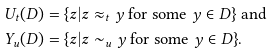<formula> <loc_0><loc_0><loc_500><loc_500>U _ { t } ( D ) & = \{ z | z \approx _ { t } y \text { for some } y \in D \} \text { and } \\ Y _ { u } ( D ) & = \{ z | z \sim _ { u } y \text { for some } y \in D \} .</formula> 